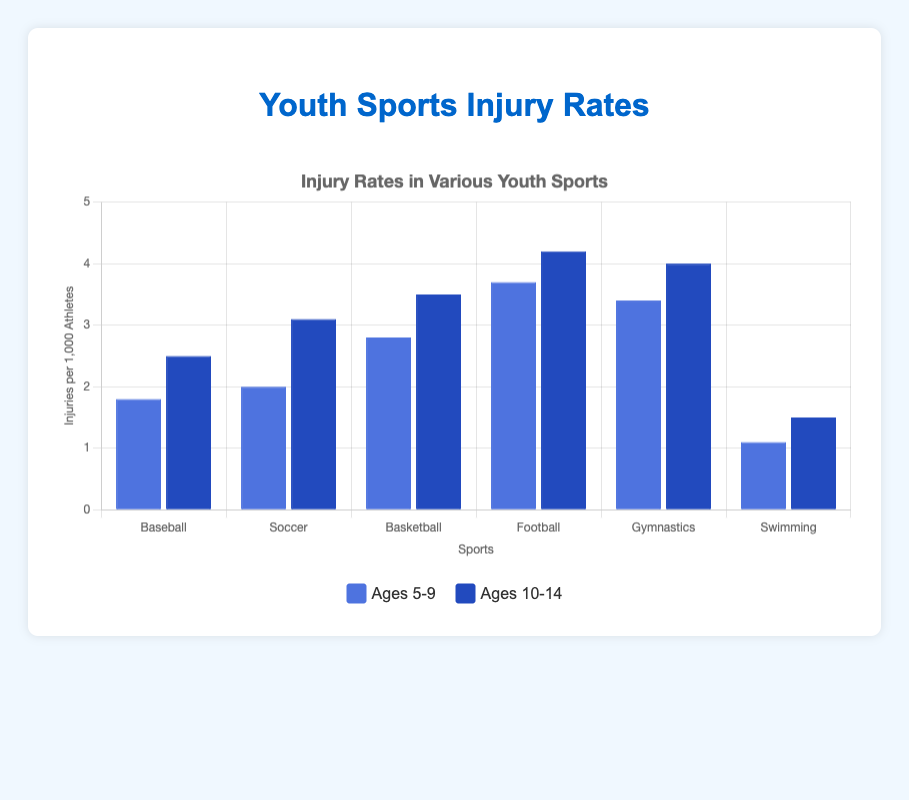Which sport has the highest injury rate for ages 5-9? The figure shows the injury rates for various sports in different age groups. For ages 5-9, Football has the highest injury rate at 3.7 per 1,000 athletes.
Answer: Football Is the injury rate for ages 10-14 higher in Soccer or Baseball? The figure shows that Soccer has an injury rate of 3.1 per 1,000 athletes for ages 10-14, while Baseball has an injury rate of 2.5 per 1,000 athletes. Therefore, Soccer has a higher injury rate than Baseball for ages 10-14.
Answer: Soccer Which age group has a higher injury rate in Gymnastics, 5-9 or 10-14? The injury rate in Gymnastics is higher for the 10-14 age group at 4.0 per 1,000 athletes, compared to the 5-9 age group, which has an injury rate of 3.4 per 1,000 athletes.
Answer: 10-14 What is the average injury rate for Swimming across both age groups? The injury rates for Swimming are 1.1 for ages 5-9 and 1.5 for ages 10-14. The average is calculated as (1.1 + 1.5) / 2 = 1.3.
Answer: 1.3 How does the injury rate for Basketball players aged 10-14 compare to those aged 5-9? The injury rate for Basketball players aged 10-14 is 3.5 per 1,000 athletes, which is higher than the 2.8 per 1,000 athletes for ages 5-9.
Answer: Higher Which sport has the lowest injury rate for ages 10-14? The figure shows that Swimming has the lowest injury rate for ages 10-14 at 1.5 per 1,000 athletes.
Answer: Swimming Are injury rates generally higher for the 10-14 age group compared to the 5-9 age group? Comparing the figures from the visual, injury rates for the 10-14 age group are consistently higher across all sports listed (Baseball, Soccer, Basketball, Football, Gymnastics, Swimming) than those for the 5-9 age group.
Answer: Yes What is the total injury rate from all sports for the age group 5-9? Summing up the injury rates for ages 5-9 across all sports: 1.8 (Baseball) + 2.0 (Soccer) + 2.8 (Basketball) + 3.7 (Football) + 3.4 (Gymnastics) + 1.1 (Swimming) = 14.8 per 1,000 athletes.
Answer: 14.8 What is the difference in injury rates between Gymnastics and Swimming for ages 5-9? For ages 5-9, Gymnastics has an injury rate of 3.4 per 1,000 athletes, while Swimming has an injury rate of 1.1. The difference is 3.4 - 1.1 = 2.3.
Answer: 2.3 